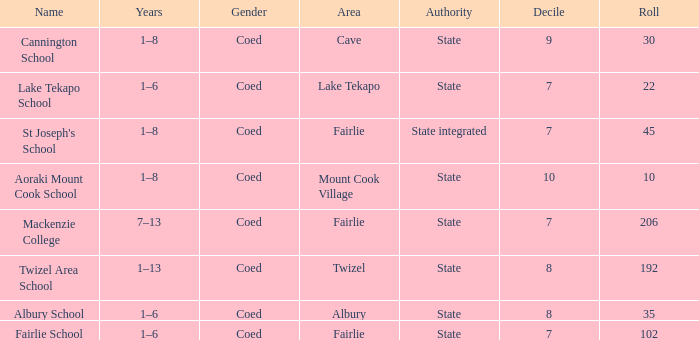What is the designated area called mackenzie college? Fairlie. 